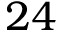Convert formula to latex. <formula><loc_0><loc_0><loc_500><loc_500>2 4</formula> 